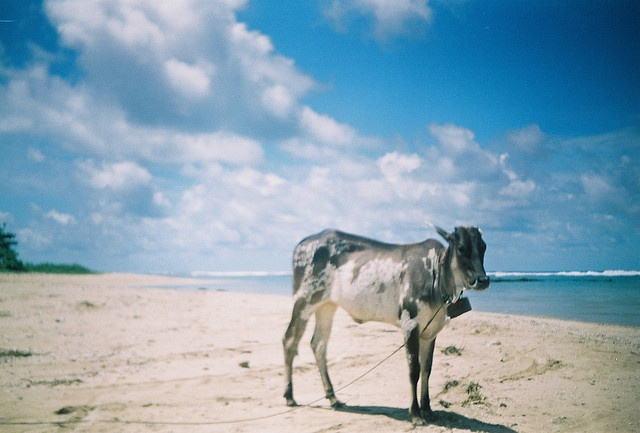Describe the objects in this image and their specific colors. I can see a cow in blue, darkgray, gray, black, and lightgray tones in this image. 